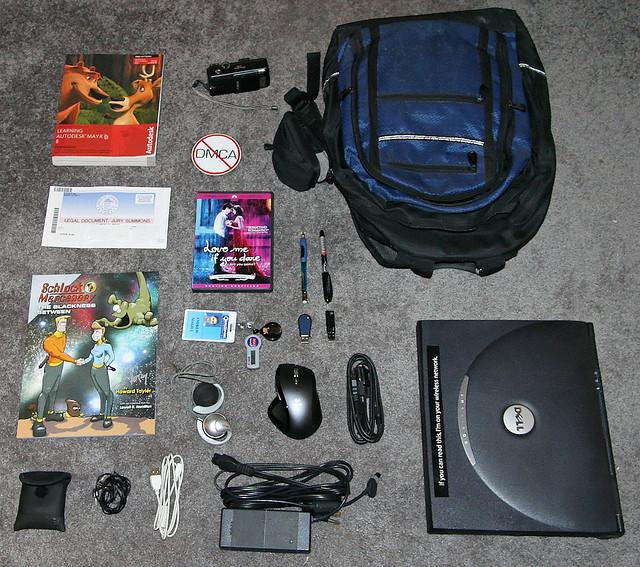What color is the mouse in this picture?
Write a very short answer. Black. What color is the backpack in the picture?
Keep it brief. Blue. Will all this items fit in the backpack?
Keep it brief. Yes. Is there a phone here?
Keep it brief. No. 